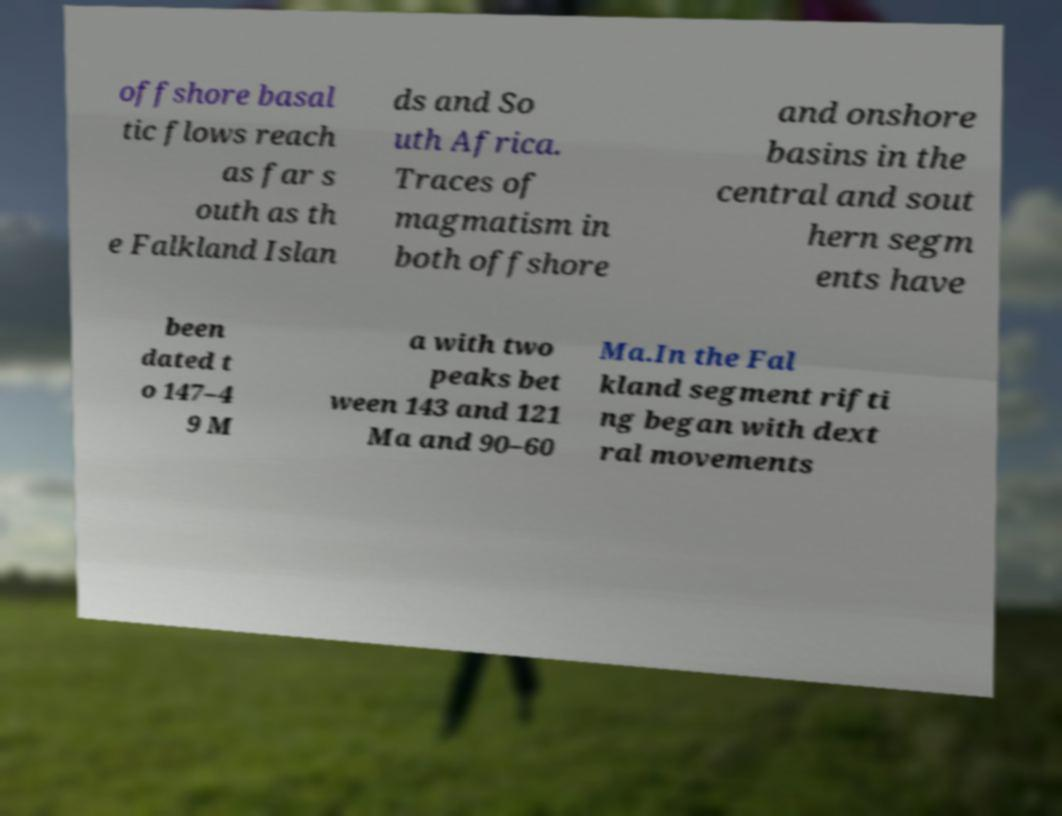There's text embedded in this image that I need extracted. Can you transcribe it verbatim? offshore basal tic flows reach as far s outh as th e Falkland Islan ds and So uth Africa. Traces of magmatism in both offshore and onshore basins in the central and sout hern segm ents have been dated t o 147–4 9 M a with two peaks bet ween 143 and 121 Ma and 90–60 Ma.In the Fal kland segment rifti ng began with dext ral movements 